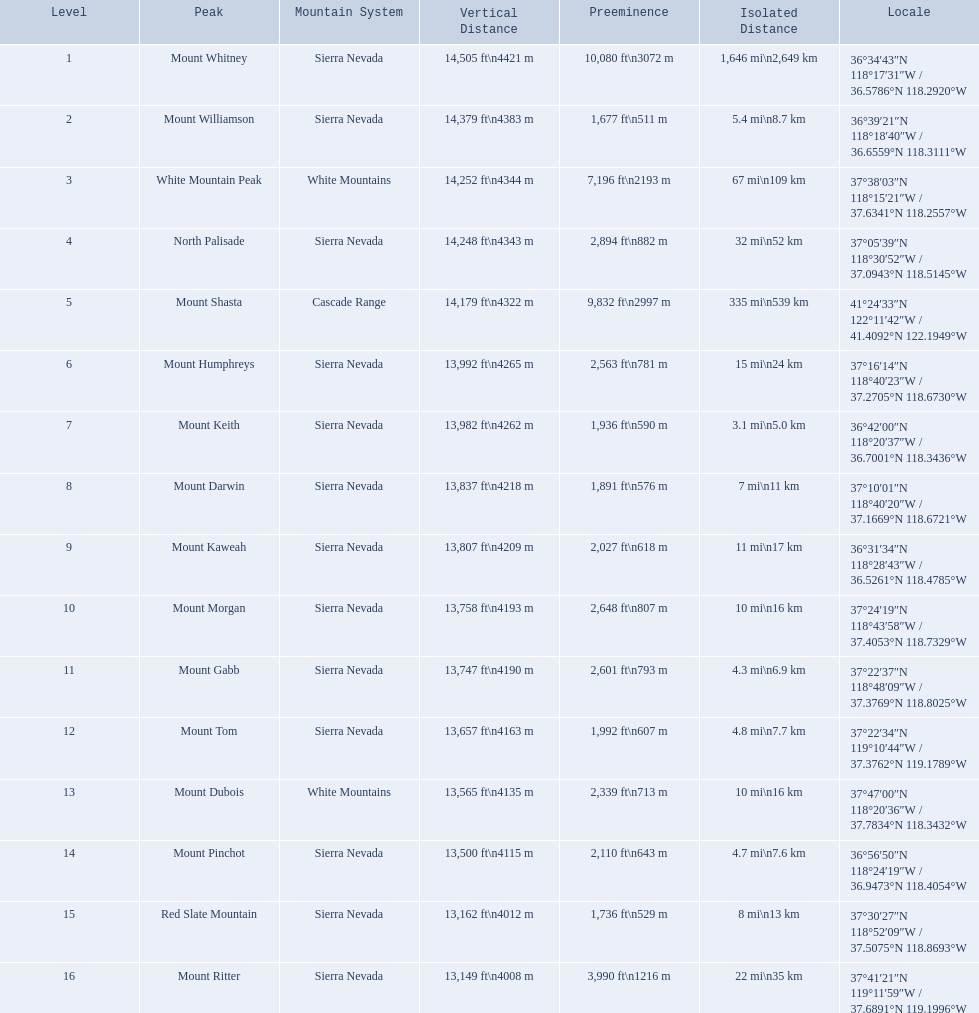What are all of the peaks? Mount Whitney, Mount Williamson, White Mountain Peak, North Palisade, Mount Shasta, Mount Humphreys, Mount Keith, Mount Darwin, Mount Kaweah, Mount Morgan, Mount Gabb, Mount Tom, Mount Dubois, Mount Pinchot, Red Slate Mountain, Mount Ritter. Where are they located? Sierra Nevada, Sierra Nevada, White Mountains, Sierra Nevada, Cascade Range, Sierra Nevada, Sierra Nevada, Sierra Nevada, Sierra Nevada, Sierra Nevada, Sierra Nevada, Sierra Nevada, White Mountains, Sierra Nevada, Sierra Nevada, Sierra Nevada. How tall are they? 14,505 ft\n4421 m, 14,379 ft\n4383 m, 14,252 ft\n4344 m, 14,248 ft\n4343 m, 14,179 ft\n4322 m, 13,992 ft\n4265 m, 13,982 ft\n4262 m, 13,837 ft\n4218 m, 13,807 ft\n4209 m, 13,758 ft\n4193 m, 13,747 ft\n4190 m, 13,657 ft\n4163 m, 13,565 ft\n4135 m, 13,500 ft\n4115 m, 13,162 ft\n4012 m, 13,149 ft\n4008 m. Parse the full table in json format. {'header': ['Level', 'Peak', 'Mountain System', 'Vertical Distance', 'Preeminence', 'Isolated Distance', 'Locale'], 'rows': [['1', 'Mount Whitney', 'Sierra Nevada', '14,505\xa0ft\\n4421\xa0m', '10,080\xa0ft\\n3072\xa0m', '1,646\xa0mi\\n2,649\xa0km', '36°34′43″N 118°17′31″W\ufeff / \ufeff36.5786°N 118.2920°W'], ['2', 'Mount Williamson', 'Sierra Nevada', '14,379\xa0ft\\n4383\xa0m', '1,677\xa0ft\\n511\xa0m', '5.4\xa0mi\\n8.7\xa0km', '36°39′21″N 118°18′40″W\ufeff / \ufeff36.6559°N 118.3111°W'], ['3', 'White Mountain Peak', 'White Mountains', '14,252\xa0ft\\n4344\xa0m', '7,196\xa0ft\\n2193\xa0m', '67\xa0mi\\n109\xa0km', '37°38′03″N 118°15′21″W\ufeff / \ufeff37.6341°N 118.2557°W'], ['4', 'North Palisade', 'Sierra Nevada', '14,248\xa0ft\\n4343\xa0m', '2,894\xa0ft\\n882\xa0m', '32\xa0mi\\n52\xa0km', '37°05′39″N 118°30′52″W\ufeff / \ufeff37.0943°N 118.5145°W'], ['5', 'Mount Shasta', 'Cascade Range', '14,179\xa0ft\\n4322\xa0m', '9,832\xa0ft\\n2997\xa0m', '335\xa0mi\\n539\xa0km', '41°24′33″N 122°11′42″W\ufeff / \ufeff41.4092°N 122.1949°W'], ['6', 'Mount Humphreys', 'Sierra Nevada', '13,992\xa0ft\\n4265\xa0m', '2,563\xa0ft\\n781\xa0m', '15\xa0mi\\n24\xa0km', '37°16′14″N 118°40′23″W\ufeff / \ufeff37.2705°N 118.6730°W'], ['7', 'Mount Keith', 'Sierra Nevada', '13,982\xa0ft\\n4262\xa0m', '1,936\xa0ft\\n590\xa0m', '3.1\xa0mi\\n5.0\xa0km', '36°42′00″N 118°20′37″W\ufeff / \ufeff36.7001°N 118.3436°W'], ['8', 'Mount Darwin', 'Sierra Nevada', '13,837\xa0ft\\n4218\xa0m', '1,891\xa0ft\\n576\xa0m', '7\xa0mi\\n11\xa0km', '37°10′01″N 118°40′20″W\ufeff / \ufeff37.1669°N 118.6721°W'], ['9', 'Mount Kaweah', 'Sierra Nevada', '13,807\xa0ft\\n4209\xa0m', '2,027\xa0ft\\n618\xa0m', '11\xa0mi\\n17\xa0km', '36°31′34″N 118°28′43″W\ufeff / \ufeff36.5261°N 118.4785°W'], ['10', 'Mount Morgan', 'Sierra Nevada', '13,758\xa0ft\\n4193\xa0m', '2,648\xa0ft\\n807\xa0m', '10\xa0mi\\n16\xa0km', '37°24′19″N 118°43′58″W\ufeff / \ufeff37.4053°N 118.7329°W'], ['11', 'Mount Gabb', 'Sierra Nevada', '13,747\xa0ft\\n4190\xa0m', '2,601\xa0ft\\n793\xa0m', '4.3\xa0mi\\n6.9\xa0km', '37°22′37″N 118°48′09″W\ufeff / \ufeff37.3769°N 118.8025°W'], ['12', 'Mount Tom', 'Sierra Nevada', '13,657\xa0ft\\n4163\xa0m', '1,992\xa0ft\\n607\xa0m', '4.8\xa0mi\\n7.7\xa0km', '37°22′34″N 119°10′44″W\ufeff / \ufeff37.3762°N 119.1789°W'], ['13', 'Mount Dubois', 'White Mountains', '13,565\xa0ft\\n4135\xa0m', '2,339\xa0ft\\n713\xa0m', '10\xa0mi\\n16\xa0km', '37°47′00″N 118°20′36″W\ufeff / \ufeff37.7834°N 118.3432°W'], ['14', 'Mount Pinchot', 'Sierra Nevada', '13,500\xa0ft\\n4115\xa0m', '2,110\xa0ft\\n643\xa0m', '4.7\xa0mi\\n7.6\xa0km', '36°56′50″N 118°24′19″W\ufeff / \ufeff36.9473°N 118.4054°W'], ['15', 'Red Slate Mountain', 'Sierra Nevada', '13,162\xa0ft\\n4012\xa0m', '1,736\xa0ft\\n529\xa0m', '8\xa0mi\\n13\xa0km', '37°30′27″N 118°52′09″W\ufeff / \ufeff37.5075°N 118.8693°W'], ['16', 'Mount Ritter', 'Sierra Nevada', '13,149\xa0ft\\n4008\xa0m', '3,990\xa0ft\\n1216\xa0m', '22\xa0mi\\n35\xa0km', '37°41′21″N 119°11′59″W\ufeff / \ufeff37.6891°N 119.1996°W']]} What about just the peaks in the sierra nevadas? 14,505 ft\n4421 m, 14,379 ft\n4383 m, 14,248 ft\n4343 m, 13,992 ft\n4265 m, 13,982 ft\n4262 m, 13,837 ft\n4218 m, 13,807 ft\n4209 m, 13,758 ft\n4193 m, 13,747 ft\n4190 m, 13,657 ft\n4163 m, 13,500 ft\n4115 m, 13,162 ft\n4012 m, 13,149 ft\n4008 m. And of those, which is the tallest? Mount Whitney. 